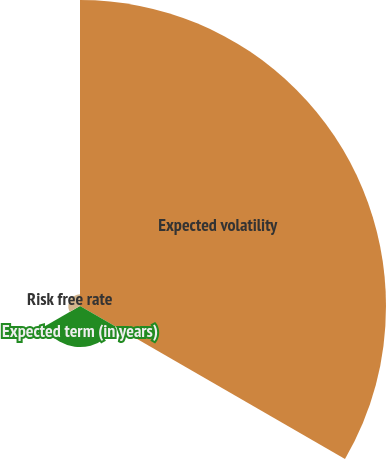Convert chart. <chart><loc_0><loc_0><loc_500><loc_500><pie_chart><fcel>Expected volatility<fcel>Expected term (in years)<fcel>Risk free rate<nl><fcel>85.29%<fcel>11.45%<fcel>3.25%<nl></chart> 